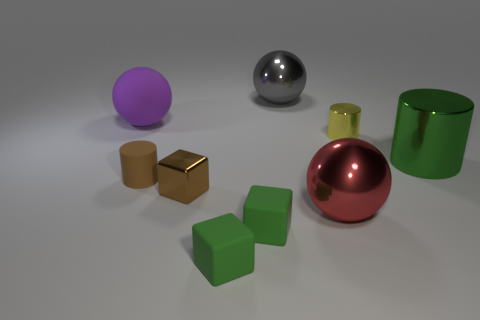Is the color of the small shiny object left of the gray shiny sphere the same as the tiny cylinder left of the gray metal object?
Your answer should be compact. Yes. Is the number of tiny things greater than the number of red metal spheres?
Make the answer very short. Yes. How many matte cylinders have the same color as the tiny shiny block?
Your answer should be compact. 1. There is another matte object that is the same shape as the big red thing; what is its color?
Provide a short and direct response. Purple. The thing that is both on the left side of the brown metallic thing and behind the tiny brown cylinder is made of what material?
Offer a very short reply. Rubber. Is the material of the green object that is behind the big red metallic ball the same as the ball that is in front of the green shiny cylinder?
Offer a very short reply. Yes. The shiny cube has what size?
Provide a short and direct response. Small. What size is the red object that is the same shape as the gray object?
Your answer should be compact. Large. There is a matte sphere; what number of rubber objects are in front of it?
Provide a short and direct response. 3. The shiny cylinder to the left of the big shiny thing to the right of the big red metal thing is what color?
Provide a short and direct response. Yellow. 